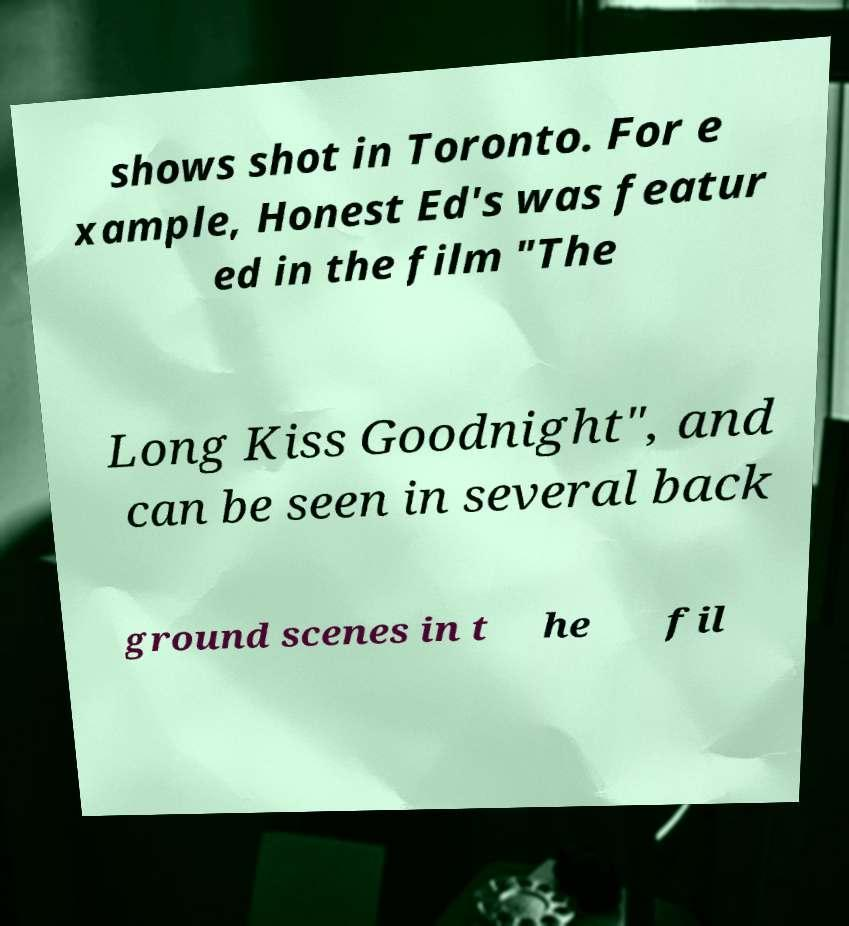Please read and relay the text visible in this image. What does it say? shows shot in Toronto. For e xample, Honest Ed's was featur ed in the film "The Long Kiss Goodnight", and can be seen in several back ground scenes in t he fil 